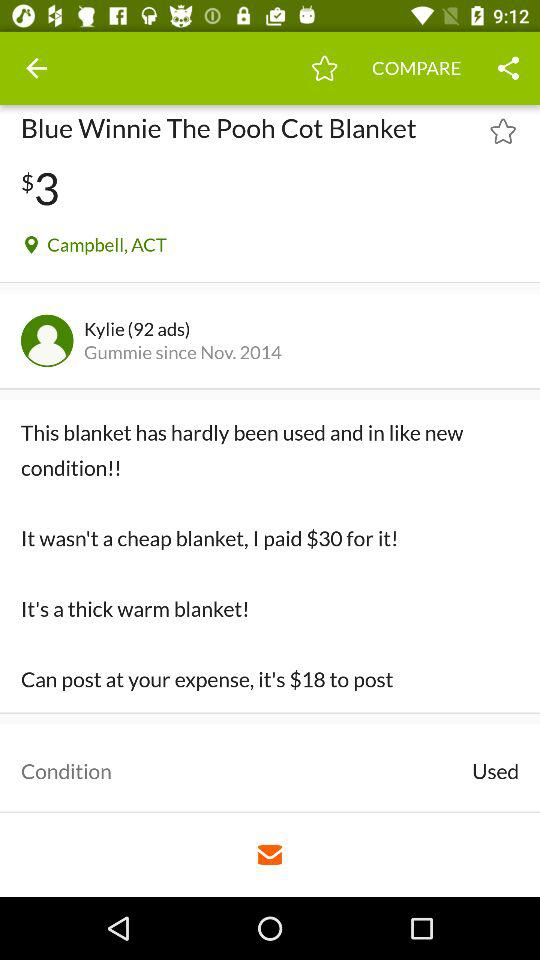What is the user name? The user name is Kylie. 